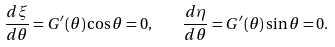Convert formula to latex. <formula><loc_0><loc_0><loc_500><loc_500>\frac { d \xi } { d \theta } = G ^ { \prime } ( \theta ) \cos \theta = 0 , \quad \frac { d \eta } { d \theta } = G ^ { \prime } ( \theta ) \sin \theta = 0 .</formula> 